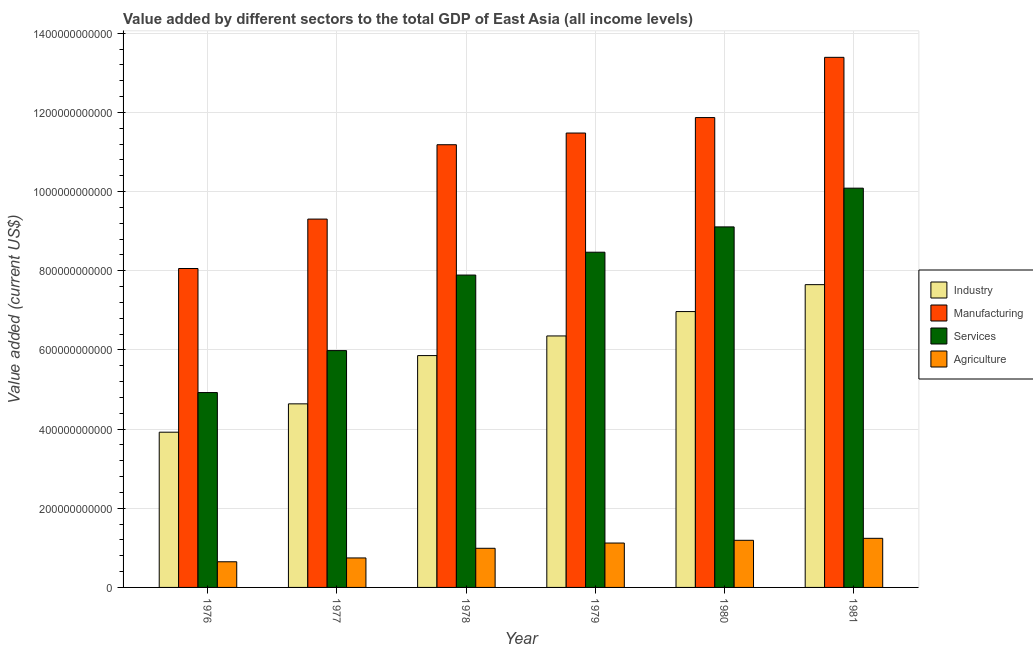How many different coloured bars are there?
Keep it short and to the point. 4. How many groups of bars are there?
Give a very brief answer. 6. Are the number of bars per tick equal to the number of legend labels?
Offer a terse response. Yes. Are the number of bars on each tick of the X-axis equal?
Offer a very short reply. Yes. What is the label of the 4th group of bars from the left?
Offer a very short reply. 1979. What is the value added by industrial sector in 1981?
Ensure brevity in your answer.  7.65e+11. Across all years, what is the maximum value added by manufacturing sector?
Your response must be concise. 1.34e+12. Across all years, what is the minimum value added by agricultural sector?
Provide a succinct answer. 6.48e+1. In which year was the value added by agricultural sector maximum?
Ensure brevity in your answer.  1981. In which year was the value added by industrial sector minimum?
Provide a succinct answer. 1976. What is the total value added by services sector in the graph?
Provide a succinct answer. 4.65e+12. What is the difference between the value added by services sector in 1977 and that in 1978?
Your answer should be very brief. -1.91e+11. What is the difference between the value added by services sector in 1979 and the value added by agricultural sector in 1977?
Provide a short and direct response. 2.49e+11. What is the average value added by services sector per year?
Ensure brevity in your answer.  7.74e+11. What is the ratio of the value added by industrial sector in 1978 to that in 1979?
Your answer should be very brief. 0.92. Is the value added by agricultural sector in 1977 less than that in 1978?
Make the answer very short. Yes. Is the difference between the value added by industrial sector in 1977 and 1980 greater than the difference between the value added by agricultural sector in 1977 and 1980?
Keep it short and to the point. No. What is the difference between the highest and the second highest value added by manufacturing sector?
Provide a short and direct response. 1.52e+11. What is the difference between the highest and the lowest value added by services sector?
Your answer should be very brief. 5.16e+11. Is the sum of the value added by manufacturing sector in 1976 and 1981 greater than the maximum value added by agricultural sector across all years?
Make the answer very short. Yes. What does the 1st bar from the left in 1977 represents?
Ensure brevity in your answer.  Industry. What does the 1st bar from the right in 1978 represents?
Give a very brief answer. Agriculture. Is it the case that in every year, the sum of the value added by industrial sector and value added by manufacturing sector is greater than the value added by services sector?
Your response must be concise. Yes. How many bars are there?
Your answer should be compact. 24. How many years are there in the graph?
Offer a terse response. 6. What is the difference between two consecutive major ticks on the Y-axis?
Offer a very short reply. 2.00e+11. Are the values on the major ticks of Y-axis written in scientific E-notation?
Ensure brevity in your answer.  No. Does the graph contain any zero values?
Your answer should be compact. No. How are the legend labels stacked?
Your response must be concise. Vertical. What is the title of the graph?
Make the answer very short. Value added by different sectors to the total GDP of East Asia (all income levels). What is the label or title of the Y-axis?
Provide a short and direct response. Value added (current US$). What is the Value added (current US$) of Industry in 1976?
Provide a short and direct response. 3.92e+11. What is the Value added (current US$) of Manufacturing in 1976?
Give a very brief answer. 8.06e+11. What is the Value added (current US$) of Services in 1976?
Provide a succinct answer. 4.92e+11. What is the Value added (current US$) in Agriculture in 1976?
Give a very brief answer. 6.48e+1. What is the Value added (current US$) of Industry in 1977?
Ensure brevity in your answer.  4.64e+11. What is the Value added (current US$) in Manufacturing in 1977?
Offer a very short reply. 9.31e+11. What is the Value added (current US$) in Services in 1977?
Your answer should be compact. 5.98e+11. What is the Value added (current US$) of Agriculture in 1977?
Keep it short and to the point. 7.45e+1. What is the Value added (current US$) of Industry in 1978?
Offer a terse response. 5.86e+11. What is the Value added (current US$) of Manufacturing in 1978?
Your response must be concise. 1.12e+12. What is the Value added (current US$) in Services in 1978?
Ensure brevity in your answer.  7.89e+11. What is the Value added (current US$) of Agriculture in 1978?
Your response must be concise. 9.89e+1. What is the Value added (current US$) in Industry in 1979?
Your response must be concise. 6.35e+11. What is the Value added (current US$) in Manufacturing in 1979?
Provide a short and direct response. 1.15e+12. What is the Value added (current US$) of Services in 1979?
Offer a very short reply. 8.47e+11. What is the Value added (current US$) of Agriculture in 1979?
Provide a short and direct response. 1.12e+11. What is the Value added (current US$) of Industry in 1980?
Provide a short and direct response. 6.97e+11. What is the Value added (current US$) in Manufacturing in 1980?
Your answer should be very brief. 1.19e+12. What is the Value added (current US$) of Services in 1980?
Offer a very short reply. 9.11e+11. What is the Value added (current US$) of Agriculture in 1980?
Ensure brevity in your answer.  1.19e+11. What is the Value added (current US$) of Industry in 1981?
Ensure brevity in your answer.  7.65e+11. What is the Value added (current US$) of Manufacturing in 1981?
Keep it short and to the point. 1.34e+12. What is the Value added (current US$) of Services in 1981?
Offer a very short reply. 1.01e+12. What is the Value added (current US$) of Agriculture in 1981?
Offer a terse response. 1.24e+11. Across all years, what is the maximum Value added (current US$) in Industry?
Your answer should be very brief. 7.65e+11. Across all years, what is the maximum Value added (current US$) of Manufacturing?
Ensure brevity in your answer.  1.34e+12. Across all years, what is the maximum Value added (current US$) in Services?
Your answer should be very brief. 1.01e+12. Across all years, what is the maximum Value added (current US$) of Agriculture?
Your response must be concise. 1.24e+11. Across all years, what is the minimum Value added (current US$) in Industry?
Offer a very short reply. 3.92e+11. Across all years, what is the minimum Value added (current US$) in Manufacturing?
Ensure brevity in your answer.  8.06e+11. Across all years, what is the minimum Value added (current US$) in Services?
Your response must be concise. 4.92e+11. Across all years, what is the minimum Value added (current US$) of Agriculture?
Provide a short and direct response. 6.48e+1. What is the total Value added (current US$) in Industry in the graph?
Your answer should be very brief. 3.54e+12. What is the total Value added (current US$) of Manufacturing in the graph?
Provide a succinct answer. 6.53e+12. What is the total Value added (current US$) of Services in the graph?
Offer a terse response. 4.65e+12. What is the total Value added (current US$) of Agriculture in the graph?
Ensure brevity in your answer.  5.93e+11. What is the difference between the Value added (current US$) in Industry in 1976 and that in 1977?
Your answer should be very brief. -7.16e+1. What is the difference between the Value added (current US$) in Manufacturing in 1976 and that in 1977?
Offer a very short reply. -1.25e+11. What is the difference between the Value added (current US$) of Services in 1976 and that in 1977?
Offer a very short reply. -1.06e+11. What is the difference between the Value added (current US$) of Agriculture in 1976 and that in 1977?
Your answer should be very brief. -9.68e+09. What is the difference between the Value added (current US$) of Industry in 1976 and that in 1978?
Provide a succinct answer. -1.94e+11. What is the difference between the Value added (current US$) in Manufacturing in 1976 and that in 1978?
Give a very brief answer. -3.13e+11. What is the difference between the Value added (current US$) of Services in 1976 and that in 1978?
Make the answer very short. -2.97e+11. What is the difference between the Value added (current US$) in Agriculture in 1976 and that in 1978?
Keep it short and to the point. -3.41e+1. What is the difference between the Value added (current US$) of Industry in 1976 and that in 1979?
Keep it short and to the point. -2.43e+11. What is the difference between the Value added (current US$) in Manufacturing in 1976 and that in 1979?
Provide a short and direct response. -3.42e+11. What is the difference between the Value added (current US$) in Services in 1976 and that in 1979?
Provide a short and direct response. -3.55e+11. What is the difference between the Value added (current US$) in Agriculture in 1976 and that in 1979?
Give a very brief answer. -4.73e+1. What is the difference between the Value added (current US$) of Industry in 1976 and that in 1980?
Make the answer very short. -3.05e+11. What is the difference between the Value added (current US$) of Manufacturing in 1976 and that in 1980?
Provide a short and direct response. -3.81e+11. What is the difference between the Value added (current US$) of Services in 1976 and that in 1980?
Make the answer very short. -4.18e+11. What is the difference between the Value added (current US$) in Agriculture in 1976 and that in 1980?
Keep it short and to the point. -5.42e+1. What is the difference between the Value added (current US$) in Industry in 1976 and that in 1981?
Give a very brief answer. -3.73e+11. What is the difference between the Value added (current US$) of Manufacturing in 1976 and that in 1981?
Your response must be concise. -5.33e+11. What is the difference between the Value added (current US$) of Services in 1976 and that in 1981?
Offer a terse response. -5.16e+11. What is the difference between the Value added (current US$) of Agriculture in 1976 and that in 1981?
Offer a terse response. -5.93e+1. What is the difference between the Value added (current US$) of Industry in 1977 and that in 1978?
Provide a short and direct response. -1.22e+11. What is the difference between the Value added (current US$) in Manufacturing in 1977 and that in 1978?
Provide a short and direct response. -1.88e+11. What is the difference between the Value added (current US$) in Services in 1977 and that in 1978?
Offer a terse response. -1.91e+11. What is the difference between the Value added (current US$) in Agriculture in 1977 and that in 1978?
Offer a very short reply. -2.44e+1. What is the difference between the Value added (current US$) in Industry in 1977 and that in 1979?
Provide a short and direct response. -1.72e+11. What is the difference between the Value added (current US$) in Manufacturing in 1977 and that in 1979?
Offer a very short reply. -2.17e+11. What is the difference between the Value added (current US$) in Services in 1977 and that in 1979?
Offer a terse response. -2.49e+11. What is the difference between the Value added (current US$) in Agriculture in 1977 and that in 1979?
Your answer should be compact. -3.76e+1. What is the difference between the Value added (current US$) of Industry in 1977 and that in 1980?
Provide a succinct answer. -2.33e+11. What is the difference between the Value added (current US$) in Manufacturing in 1977 and that in 1980?
Make the answer very short. -2.56e+11. What is the difference between the Value added (current US$) of Services in 1977 and that in 1980?
Provide a short and direct response. -3.13e+11. What is the difference between the Value added (current US$) in Agriculture in 1977 and that in 1980?
Your response must be concise. -4.46e+1. What is the difference between the Value added (current US$) of Industry in 1977 and that in 1981?
Keep it short and to the point. -3.01e+11. What is the difference between the Value added (current US$) of Manufacturing in 1977 and that in 1981?
Ensure brevity in your answer.  -4.09e+11. What is the difference between the Value added (current US$) of Services in 1977 and that in 1981?
Offer a very short reply. -4.10e+11. What is the difference between the Value added (current US$) in Agriculture in 1977 and that in 1981?
Keep it short and to the point. -4.96e+1. What is the difference between the Value added (current US$) of Industry in 1978 and that in 1979?
Your answer should be very brief. -4.96e+1. What is the difference between the Value added (current US$) in Manufacturing in 1978 and that in 1979?
Your answer should be compact. -2.95e+1. What is the difference between the Value added (current US$) in Services in 1978 and that in 1979?
Make the answer very short. -5.77e+1. What is the difference between the Value added (current US$) in Agriculture in 1978 and that in 1979?
Offer a very short reply. -1.33e+1. What is the difference between the Value added (current US$) in Industry in 1978 and that in 1980?
Make the answer very short. -1.11e+11. What is the difference between the Value added (current US$) in Manufacturing in 1978 and that in 1980?
Offer a terse response. -6.86e+1. What is the difference between the Value added (current US$) in Services in 1978 and that in 1980?
Give a very brief answer. -1.22e+11. What is the difference between the Value added (current US$) in Agriculture in 1978 and that in 1980?
Your response must be concise. -2.02e+1. What is the difference between the Value added (current US$) in Industry in 1978 and that in 1981?
Keep it short and to the point. -1.79e+11. What is the difference between the Value added (current US$) in Manufacturing in 1978 and that in 1981?
Your answer should be very brief. -2.21e+11. What is the difference between the Value added (current US$) of Services in 1978 and that in 1981?
Provide a short and direct response. -2.20e+11. What is the difference between the Value added (current US$) in Agriculture in 1978 and that in 1981?
Ensure brevity in your answer.  -2.52e+1. What is the difference between the Value added (current US$) in Industry in 1979 and that in 1980?
Ensure brevity in your answer.  -6.16e+1. What is the difference between the Value added (current US$) in Manufacturing in 1979 and that in 1980?
Provide a short and direct response. -3.91e+1. What is the difference between the Value added (current US$) of Services in 1979 and that in 1980?
Your response must be concise. -6.40e+1. What is the difference between the Value added (current US$) of Agriculture in 1979 and that in 1980?
Provide a succinct answer. -6.93e+09. What is the difference between the Value added (current US$) of Industry in 1979 and that in 1981?
Ensure brevity in your answer.  -1.30e+11. What is the difference between the Value added (current US$) in Manufacturing in 1979 and that in 1981?
Offer a terse response. -1.91e+11. What is the difference between the Value added (current US$) in Services in 1979 and that in 1981?
Provide a succinct answer. -1.62e+11. What is the difference between the Value added (current US$) of Agriculture in 1979 and that in 1981?
Offer a very short reply. -1.20e+1. What is the difference between the Value added (current US$) in Industry in 1980 and that in 1981?
Offer a very short reply. -6.80e+1. What is the difference between the Value added (current US$) in Manufacturing in 1980 and that in 1981?
Give a very brief answer. -1.52e+11. What is the difference between the Value added (current US$) of Services in 1980 and that in 1981?
Your answer should be very brief. -9.78e+1. What is the difference between the Value added (current US$) of Agriculture in 1980 and that in 1981?
Provide a succinct answer. -5.02e+09. What is the difference between the Value added (current US$) in Industry in 1976 and the Value added (current US$) in Manufacturing in 1977?
Make the answer very short. -5.38e+11. What is the difference between the Value added (current US$) of Industry in 1976 and the Value added (current US$) of Services in 1977?
Offer a very short reply. -2.06e+11. What is the difference between the Value added (current US$) in Industry in 1976 and the Value added (current US$) in Agriculture in 1977?
Provide a short and direct response. 3.18e+11. What is the difference between the Value added (current US$) of Manufacturing in 1976 and the Value added (current US$) of Services in 1977?
Offer a very short reply. 2.07e+11. What is the difference between the Value added (current US$) of Manufacturing in 1976 and the Value added (current US$) of Agriculture in 1977?
Provide a short and direct response. 7.31e+11. What is the difference between the Value added (current US$) in Services in 1976 and the Value added (current US$) in Agriculture in 1977?
Provide a succinct answer. 4.18e+11. What is the difference between the Value added (current US$) in Industry in 1976 and the Value added (current US$) in Manufacturing in 1978?
Ensure brevity in your answer.  -7.26e+11. What is the difference between the Value added (current US$) of Industry in 1976 and the Value added (current US$) of Services in 1978?
Provide a succinct answer. -3.97e+11. What is the difference between the Value added (current US$) in Industry in 1976 and the Value added (current US$) in Agriculture in 1978?
Offer a terse response. 2.93e+11. What is the difference between the Value added (current US$) in Manufacturing in 1976 and the Value added (current US$) in Services in 1978?
Make the answer very short. 1.65e+1. What is the difference between the Value added (current US$) in Manufacturing in 1976 and the Value added (current US$) in Agriculture in 1978?
Offer a very short reply. 7.07e+11. What is the difference between the Value added (current US$) in Services in 1976 and the Value added (current US$) in Agriculture in 1978?
Provide a short and direct response. 3.93e+11. What is the difference between the Value added (current US$) in Industry in 1976 and the Value added (current US$) in Manufacturing in 1979?
Give a very brief answer. -7.56e+11. What is the difference between the Value added (current US$) in Industry in 1976 and the Value added (current US$) in Services in 1979?
Your response must be concise. -4.55e+11. What is the difference between the Value added (current US$) of Industry in 1976 and the Value added (current US$) of Agriculture in 1979?
Give a very brief answer. 2.80e+11. What is the difference between the Value added (current US$) of Manufacturing in 1976 and the Value added (current US$) of Services in 1979?
Give a very brief answer. -4.12e+1. What is the difference between the Value added (current US$) of Manufacturing in 1976 and the Value added (current US$) of Agriculture in 1979?
Ensure brevity in your answer.  6.94e+11. What is the difference between the Value added (current US$) in Services in 1976 and the Value added (current US$) in Agriculture in 1979?
Make the answer very short. 3.80e+11. What is the difference between the Value added (current US$) in Industry in 1976 and the Value added (current US$) in Manufacturing in 1980?
Provide a succinct answer. -7.95e+11. What is the difference between the Value added (current US$) in Industry in 1976 and the Value added (current US$) in Services in 1980?
Provide a succinct answer. -5.19e+11. What is the difference between the Value added (current US$) in Industry in 1976 and the Value added (current US$) in Agriculture in 1980?
Your answer should be very brief. 2.73e+11. What is the difference between the Value added (current US$) in Manufacturing in 1976 and the Value added (current US$) in Services in 1980?
Offer a very short reply. -1.05e+11. What is the difference between the Value added (current US$) in Manufacturing in 1976 and the Value added (current US$) in Agriculture in 1980?
Keep it short and to the point. 6.87e+11. What is the difference between the Value added (current US$) of Services in 1976 and the Value added (current US$) of Agriculture in 1980?
Make the answer very short. 3.73e+11. What is the difference between the Value added (current US$) of Industry in 1976 and the Value added (current US$) of Manufacturing in 1981?
Your answer should be compact. -9.47e+11. What is the difference between the Value added (current US$) in Industry in 1976 and the Value added (current US$) in Services in 1981?
Your answer should be compact. -6.16e+11. What is the difference between the Value added (current US$) of Industry in 1976 and the Value added (current US$) of Agriculture in 1981?
Provide a short and direct response. 2.68e+11. What is the difference between the Value added (current US$) in Manufacturing in 1976 and the Value added (current US$) in Services in 1981?
Your answer should be compact. -2.03e+11. What is the difference between the Value added (current US$) in Manufacturing in 1976 and the Value added (current US$) in Agriculture in 1981?
Your answer should be very brief. 6.82e+11. What is the difference between the Value added (current US$) of Services in 1976 and the Value added (current US$) of Agriculture in 1981?
Offer a very short reply. 3.68e+11. What is the difference between the Value added (current US$) in Industry in 1977 and the Value added (current US$) in Manufacturing in 1978?
Give a very brief answer. -6.55e+11. What is the difference between the Value added (current US$) of Industry in 1977 and the Value added (current US$) of Services in 1978?
Provide a succinct answer. -3.25e+11. What is the difference between the Value added (current US$) of Industry in 1977 and the Value added (current US$) of Agriculture in 1978?
Your answer should be compact. 3.65e+11. What is the difference between the Value added (current US$) in Manufacturing in 1977 and the Value added (current US$) in Services in 1978?
Provide a succinct answer. 1.41e+11. What is the difference between the Value added (current US$) in Manufacturing in 1977 and the Value added (current US$) in Agriculture in 1978?
Your answer should be very brief. 8.32e+11. What is the difference between the Value added (current US$) of Services in 1977 and the Value added (current US$) of Agriculture in 1978?
Make the answer very short. 4.99e+11. What is the difference between the Value added (current US$) of Industry in 1977 and the Value added (current US$) of Manufacturing in 1979?
Your answer should be compact. -6.84e+11. What is the difference between the Value added (current US$) of Industry in 1977 and the Value added (current US$) of Services in 1979?
Give a very brief answer. -3.83e+11. What is the difference between the Value added (current US$) in Industry in 1977 and the Value added (current US$) in Agriculture in 1979?
Your response must be concise. 3.52e+11. What is the difference between the Value added (current US$) in Manufacturing in 1977 and the Value added (current US$) in Services in 1979?
Your response must be concise. 8.37e+1. What is the difference between the Value added (current US$) of Manufacturing in 1977 and the Value added (current US$) of Agriculture in 1979?
Your response must be concise. 8.18e+11. What is the difference between the Value added (current US$) in Services in 1977 and the Value added (current US$) in Agriculture in 1979?
Make the answer very short. 4.86e+11. What is the difference between the Value added (current US$) of Industry in 1977 and the Value added (current US$) of Manufacturing in 1980?
Offer a terse response. -7.23e+11. What is the difference between the Value added (current US$) in Industry in 1977 and the Value added (current US$) in Services in 1980?
Ensure brevity in your answer.  -4.47e+11. What is the difference between the Value added (current US$) in Industry in 1977 and the Value added (current US$) in Agriculture in 1980?
Make the answer very short. 3.45e+11. What is the difference between the Value added (current US$) in Manufacturing in 1977 and the Value added (current US$) in Services in 1980?
Make the answer very short. 1.97e+1. What is the difference between the Value added (current US$) of Manufacturing in 1977 and the Value added (current US$) of Agriculture in 1980?
Offer a very short reply. 8.11e+11. What is the difference between the Value added (current US$) in Services in 1977 and the Value added (current US$) in Agriculture in 1980?
Offer a terse response. 4.79e+11. What is the difference between the Value added (current US$) in Industry in 1977 and the Value added (current US$) in Manufacturing in 1981?
Keep it short and to the point. -8.75e+11. What is the difference between the Value added (current US$) of Industry in 1977 and the Value added (current US$) of Services in 1981?
Ensure brevity in your answer.  -5.45e+11. What is the difference between the Value added (current US$) of Industry in 1977 and the Value added (current US$) of Agriculture in 1981?
Ensure brevity in your answer.  3.40e+11. What is the difference between the Value added (current US$) in Manufacturing in 1977 and the Value added (current US$) in Services in 1981?
Your answer should be compact. -7.81e+1. What is the difference between the Value added (current US$) of Manufacturing in 1977 and the Value added (current US$) of Agriculture in 1981?
Offer a terse response. 8.06e+11. What is the difference between the Value added (current US$) of Services in 1977 and the Value added (current US$) of Agriculture in 1981?
Provide a short and direct response. 4.74e+11. What is the difference between the Value added (current US$) in Industry in 1978 and the Value added (current US$) in Manufacturing in 1979?
Provide a succinct answer. -5.62e+11. What is the difference between the Value added (current US$) in Industry in 1978 and the Value added (current US$) in Services in 1979?
Offer a terse response. -2.61e+11. What is the difference between the Value added (current US$) of Industry in 1978 and the Value added (current US$) of Agriculture in 1979?
Provide a short and direct response. 4.74e+11. What is the difference between the Value added (current US$) of Manufacturing in 1978 and the Value added (current US$) of Services in 1979?
Ensure brevity in your answer.  2.72e+11. What is the difference between the Value added (current US$) in Manufacturing in 1978 and the Value added (current US$) in Agriculture in 1979?
Offer a very short reply. 1.01e+12. What is the difference between the Value added (current US$) of Services in 1978 and the Value added (current US$) of Agriculture in 1979?
Make the answer very short. 6.77e+11. What is the difference between the Value added (current US$) of Industry in 1978 and the Value added (current US$) of Manufacturing in 1980?
Offer a very short reply. -6.01e+11. What is the difference between the Value added (current US$) of Industry in 1978 and the Value added (current US$) of Services in 1980?
Give a very brief answer. -3.25e+11. What is the difference between the Value added (current US$) of Industry in 1978 and the Value added (current US$) of Agriculture in 1980?
Provide a short and direct response. 4.67e+11. What is the difference between the Value added (current US$) in Manufacturing in 1978 and the Value added (current US$) in Services in 1980?
Offer a very short reply. 2.08e+11. What is the difference between the Value added (current US$) of Manufacturing in 1978 and the Value added (current US$) of Agriculture in 1980?
Ensure brevity in your answer.  9.99e+11. What is the difference between the Value added (current US$) of Services in 1978 and the Value added (current US$) of Agriculture in 1980?
Your response must be concise. 6.70e+11. What is the difference between the Value added (current US$) of Industry in 1978 and the Value added (current US$) of Manufacturing in 1981?
Your response must be concise. -7.53e+11. What is the difference between the Value added (current US$) of Industry in 1978 and the Value added (current US$) of Services in 1981?
Your answer should be very brief. -4.23e+11. What is the difference between the Value added (current US$) of Industry in 1978 and the Value added (current US$) of Agriculture in 1981?
Make the answer very short. 4.62e+11. What is the difference between the Value added (current US$) of Manufacturing in 1978 and the Value added (current US$) of Services in 1981?
Offer a terse response. 1.10e+11. What is the difference between the Value added (current US$) in Manufacturing in 1978 and the Value added (current US$) in Agriculture in 1981?
Offer a very short reply. 9.94e+11. What is the difference between the Value added (current US$) of Services in 1978 and the Value added (current US$) of Agriculture in 1981?
Ensure brevity in your answer.  6.65e+11. What is the difference between the Value added (current US$) of Industry in 1979 and the Value added (current US$) of Manufacturing in 1980?
Your answer should be compact. -5.52e+11. What is the difference between the Value added (current US$) of Industry in 1979 and the Value added (current US$) of Services in 1980?
Provide a short and direct response. -2.75e+11. What is the difference between the Value added (current US$) in Industry in 1979 and the Value added (current US$) in Agriculture in 1980?
Keep it short and to the point. 5.16e+11. What is the difference between the Value added (current US$) of Manufacturing in 1979 and the Value added (current US$) of Services in 1980?
Offer a very short reply. 2.37e+11. What is the difference between the Value added (current US$) of Manufacturing in 1979 and the Value added (current US$) of Agriculture in 1980?
Your answer should be compact. 1.03e+12. What is the difference between the Value added (current US$) of Services in 1979 and the Value added (current US$) of Agriculture in 1980?
Your response must be concise. 7.28e+11. What is the difference between the Value added (current US$) in Industry in 1979 and the Value added (current US$) in Manufacturing in 1981?
Provide a short and direct response. -7.04e+11. What is the difference between the Value added (current US$) of Industry in 1979 and the Value added (current US$) of Services in 1981?
Offer a terse response. -3.73e+11. What is the difference between the Value added (current US$) of Industry in 1979 and the Value added (current US$) of Agriculture in 1981?
Ensure brevity in your answer.  5.11e+11. What is the difference between the Value added (current US$) in Manufacturing in 1979 and the Value added (current US$) in Services in 1981?
Offer a terse response. 1.39e+11. What is the difference between the Value added (current US$) of Manufacturing in 1979 and the Value added (current US$) of Agriculture in 1981?
Keep it short and to the point. 1.02e+12. What is the difference between the Value added (current US$) in Services in 1979 and the Value added (current US$) in Agriculture in 1981?
Offer a very short reply. 7.23e+11. What is the difference between the Value added (current US$) of Industry in 1980 and the Value added (current US$) of Manufacturing in 1981?
Your response must be concise. -6.42e+11. What is the difference between the Value added (current US$) of Industry in 1980 and the Value added (current US$) of Services in 1981?
Your answer should be compact. -3.12e+11. What is the difference between the Value added (current US$) in Industry in 1980 and the Value added (current US$) in Agriculture in 1981?
Ensure brevity in your answer.  5.73e+11. What is the difference between the Value added (current US$) of Manufacturing in 1980 and the Value added (current US$) of Services in 1981?
Ensure brevity in your answer.  1.78e+11. What is the difference between the Value added (current US$) in Manufacturing in 1980 and the Value added (current US$) in Agriculture in 1981?
Provide a succinct answer. 1.06e+12. What is the difference between the Value added (current US$) of Services in 1980 and the Value added (current US$) of Agriculture in 1981?
Provide a succinct answer. 7.87e+11. What is the average Value added (current US$) in Industry per year?
Provide a short and direct response. 5.90e+11. What is the average Value added (current US$) of Manufacturing per year?
Provide a succinct answer. 1.09e+12. What is the average Value added (current US$) in Services per year?
Provide a succinct answer. 7.74e+11. What is the average Value added (current US$) in Agriculture per year?
Give a very brief answer. 9.89e+1. In the year 1976, what is the difference between the Value added (current US$) of Industry and Value added (current US$) of Manufacturing?
Keep it short and to the point. -4.14e+11. In the year 1976, what is the difference between the Value added (current US$) in Industry and Value added (current US$) in Services?
Your answer should be compact. -1.00e+11. In the year 1976, what is the difference between the Value added (current US$) in Industry and Value added (current US$) in Agriculture?
Give a very brief answer. 3.27e+11. In the year 1976, what is the difference between the Value added (current US$) of Manufacturing and Value added (current US$) of Services?
Your answer should be compact. 3.13e+11. In the year 1976, what is the difference between the Value added (current US$) of Manufacturing and Value added (current US$) of Agriculture?
Offer a very short reply. 7.41e+11. In the year 1976, what is the difference between the Value added (current US$) of Services and Value added (current US$) of Agriculture?
Ensure brevity in your answer.  4.27e+11. In the year 1977, what is the difference between the Value added (current US$) of Industry and Value added (current US$) of Manufacturing?
Keep it short and to the point. -4.67e+11. In the year 1977, what is the difference between the Value added (current US$) of Industry and Value added (current US$) of Services?
Your response must be concise. -1.35e+11. In the year 1977, what is the difference between the Value added (current US$) of Industry and Value added (current US$) of Agriculture?
Offer a terse response. 3.89e+11. In the year 1977, what is the difference between the Value added (current US$) of Manufacturing and Value added (current US$) of Services?
Ensure brevity in your answer.  3.32e+11. In the year 1977, what is the difference between the Value added (current US$) in Manufacturing and Value added (current US$) in Agriculture?
Provide a succinct answer. 8.56e+11. In the year 1977, what is the difference between the Value added (current US$) of Services and Value added (current US$) of Agriculture?
Offer a very short reply. 5.24e+11. In the year 1978, what is the difference between the Value added (current US$) in Industry and Value added (current US$) in Manufacturing?
Your answer should be compact. -5.33e+11. In the year 1978, what is the difference between the Value added (current US$) of Industry and Value added (current US$) of Services?
Provide a short and direct response. -2.03e+11. In the year 1978, what is the difference between the Value added (current US$) in Industry and Value added (current US$) in Agriculture?
Offer a terse response. 4.87e+11. In the year 1978, what is the difference between the Value added (current US$) of Manufacturing and Value added (current US$) of Services?
Make the answer very short. 3.29e+11. In the year 1978, what is the difference between the Value added (current US$) of Manufacturing and Value added (current US$) of Agriculture?
Offer a terse response. 1.02e+12. In the year 1978, what is the difference between the Value added (current US$) of Services and Value added (current US$) of Agriculture?
Your response must be concise. 6.90e+11. In the year 1979, what is the difference between the Value added (current US$) in Industry and Value added (current US$) in Manufacturing?
Make the answer very short. -5.13e+11. In the year 1979, what is the difference between the Value added (current US$) in Industry and Value added (current US$) in Services?
Your answer should be very brief. -2.12e+11. In the year 1979, what is the difference between the Value added (current US$) in Industry and Value added (current US$) in Agriculture?
Your answer should be compact. 5.23e+11. In the year 1979, what is the difference between the Value added (current US$) of Manufacturing and Value added (current US$) of Services?
Your response must be concise. 3.01e+11. In the year 1979, what is the difference between the Value added (current US$) of Manufacturing and Value added (current US$) of Agriculture?
Keep it short and to the point. 1.04e+12. In the year 1979, what is the difference between the Value added (current US$) in Services and Value added (current US$) in Agriculture?
Offer a very short reply. 7.35e+11. In the year 1980, what is the difference between the Value added (current US$) in Industry and Value added (current US$) in Manufacturing?
Provide a succinct answer. -4.90e+11. In the year 1980, what is the difference between the Value added (current US$) of Industry and Value added (current US$) of Services?
Your answer should be very brief. -2.14e+11. In the year 1980, what is the difference between the Value added (current US$) of Industry and Value added (current US$) of Agriculture?
Your answer should be very brief. 5.78e+11. In the year 1980, what is the difference between the Value added (current US$) of Manufacturing and Value added (current US$) of Services?
Ensure brevity in your answer.  2.76e+11. In the year 1980, what is the difference between the Value added (current US$) in Manufacturing and Value added (current US$) in Agriculture?
Your response must be concise. 1.07e+12. In the year 1980, what is the difference between the Value added (current US$) of Services and Value added (current US$) of Agriculture?
Ensure brevity in your answer.  7.92e+11. In the year 1981, what is the difference between the Value added (current US$) of Industry and Value added (current US$) of Manufacturing?
Offer a terse response. -5.74e+11. In the year 1981, what is the difference between the Value added (current US$) in Industry and Value added (current US$) in Services?
Provide a succinct answer. -2.44e+11. In the year 1981, what is the difference between the Value added (current US$) of Industry and Value added (current US$) of Agriculture?
Provide a succinct answer. 6.41e+11. In the year 1981, what is the difference between the Value added (current US$) in Manufacturing and Value added (current US$) in Services?
Keep it short and to the point. 3.31e+11. In the year 1981, what is the difference between the Value added (current US$) in Manufacturing and Value added (current US$) in Agriculture?
Make the answer very short. 1.22e+12. In the year 1981, what is the difference between the Value added (current US$) in Services and Value added (current US$) in Agriculture?
Provide a succinct answer. 8.85e+11. What is the ratio of the Value added (current US$) in Industry in 1976 to that in 1977?
Ensure brevity in your answer.  0.85. What is the ratio of the Value added (current US$) in Manufacturing in 1976 to that in 1977?
Make the answer very short. 0.87. What is the ratio of the Value added (current US$) in Services in 1976 to that in 1977?
Make the answer very short. 0.82. What is the ratio of the Value added (current US$) of Agriculture in 1976 to that in 1977?
Your answer should be very brief. 0.87. What is the ratio of the Value added (current US$) in Industry in 1976 to that in 1978?
Your response must be concise. 0.67. What is the ratio of the Value added (current US$) in Manufacturing in 1976 to that in 1978?
Your answer should be compact. 0.72. What is the ratio of the Value added (current US$) of Services in 1976 to that in 1978?
Keep it short and to the point. 0.62. What is the ratio of the Value added (current US$) in Agriculture in 1976 to that in 1978?
Provide a succinct answer. 0.66. What is the ratio of the Value added (current US$) of Industry in 1976 to that in 1979?
Your answer should be compact. 0.62. What is the ratio of the Value added (current US$) in Manufacturing in 1976 to that in 1979?
Offer a very short reply. 0.7. What is the ratio of the Value added (current US$) of Services in 1976 to that in 1979?
Give a very brief answer. 0.58. What is the ratio of the Value added (current US$) of Agriculture in 1976 to that in 1979?
Your answer should be compact. 0.58. What is the ratio of the Value added (current US$) in Industry in 1976 to that in 1980?
Provide a short and direct response. 0.56. What is the ratio of the Value added (current US$) of Manufacturing in 1976 to that in 1980?
Make the answer very short. 0.68. What is the ratio of the Value added (current US$) of Services in 1976 to that in 1980?
Your answer should be compact. 0.54. What is the ratio of the Value added (current US$) in Agriculture in 1976 to that in 1980?
Provide a short and direct response. 0.54. What is the ratio of the Value added (current US$) in Industry in 1976 to that in 1981?
Your answer should be very brief. 0.51. What is the ratio of the Value added (current US$) in Manufacturing in 1976 to that in 1981?
Your answer should be very brief. 0.6. What is the ratio of the Value added (current US$) of Services in 1976 to that in 1981?
Your answer should be compact. 0.49. What is the ratio of the Value added (current US$) of Agriculture in 1976 to that in 1981?
Offer a terse response. 0.52. What is the ratio of the Value added (current US$) in Industry in 1977 to that in 1978?
Give a very brief answer. 0.79. What is the ratio of the Value added (current US$) of Manufacturing in 1977 to that in 1978?
Offer a terse response. 0.83. What is the ratio of the Value added (current US$) of Services in 1977 to that in 1978?
Provide a short and direct response. 0.76. What is the ratio of the Value added (current US$) of Agriculture in 1977 to that in 1978?
Your answer should be compact. 0.75. What is the ratio of the Value added (current US$) in Industry in 1977 to that in 1979?
Provide a succinct answer. 0.73. What is the ratio of the Value added (current US$) in Manufacturing in 1977 to that in 1979?
Provide a succinct answer. 0.81. What is the ratio of the Value added (current US$) of Services in 1977 to that in 1979?
Offer a very short reply. 0.71. What is the ratio of the Value added (current US$) of Agriculture in 1977 to that in 1979?
Offer a terse response. 0.66. What is the ratio of the Value added (current US$) in Industry in 1977 to that in 1980?
Offer a terse response. 0.67. What is the ratio of the Value added (current US$) of Manufacturing in 1977 to that in 1980?
Your answer should be very brief. 0.78. What is the ratio of the Value added (current US$) of Services in 1977 to that in 1980?
Your answer should be very brief. 0.66. What is the ratio of the Value added (current US$) in Agriculture in 1977 to that in 1980?
Your answer should be compact. 0.63. What is the ratio of the Value added (current US$) in Industry in 1977 to that in 1981?
Your answer should be very brief. 0.61. What is the ratio of the Value added (current US$) of Manufacturing in 1977 to that in 1981?
Provide a short and direct response. 0.69. What is the ratio of the Value added (current US$) in Services in 1977 to that in 1981?
Make the answer very short. 0.59. What is the ratio of the Value added (current US$) of Agriculture in 1977 to that in 1981?
Offer a very short reply. 0.6. What is the ratio of the Value added (current US$) of Industry in 1978 to that in 1979?
Your response must be concise. 0.92. What is the ratio of the Value added (current US$) of Manufacturing in 1978 to that in 1979?
Ensure brevity in your answer.  0.97. What is the ratio of the Value added (current US$) in Services in 1978 to that in 1979?
Your response must be concise. 0.93. What is the ratio of the Value added (current US$) of Agriculture in 1978 to that in 1979?
Give a very brief answer. 0.88. What is the ratio of the Value added (current US$) of Industry in 1978 to that in 1980?
Keep it short and to the point. 0.84. What is the ratio of the Value added (current US$) of Manufacturing in 1978 to that in 1980?
Ensure brevity in your answer.  0.94. What is the ratio of the Value added (current US$) of Services in 1978 to that in 1980?
Provide a short and direct response. 0.87. What is the ratio of the Value added (current US$) of Agriculture in 1978 to that in 1980?
Offer a terse response. 0.83. What is the ratio of the Value added (current US$) in Industry in 1978 to that in 1981?
Make the answer very short. 0.77. What is the ratio of the Value added (current US$) in Manufacturing in 1978 to that in 1981?
Offer a terse response. 0.84. What is the ratio of the Value added (current US$) of Services in 1978 to that in 1981?
Offer a terse response. 0.78. What is the ratio of the Value added (current US$) in Agriculture in 1978 to that in 1981?
Make the answer very short. 0.8. What is the ratio of the Value added (current US$) in Industry in 1979 to that in 1980?
Keep it short and to the point. 0.91. What is the ratio of the Value added (current US$) in Manufacturing in 1979 to that in 1980?
Ensure brevity in your answer.  0.97. What is the ratio of the Value added (current US$) of Services in 1979 to that in 1980?
Make the answer very short. 0.93. What is the ratio of the Value added (current US$) of Agriculture in 1979 to that in 1980?
Your answer should be compact. 0.94. What is the ratio of the Value added (current US$) of Industry in 1979 to that in 1981?
Provide a short and direct response. 0.83. What is the ratio of the Value added (current US$) in Manufacturing in 1979 to that in 1981?
Make the answer very short. 0.86. What is the ratio of the Value added (current US$) of Services in 1979 to that in 1981?
Ensure brevity in your answer.  0.84. What is the ratio of the Value added (current US$) of Agriculture in 1979 to that in 1981?
Your answer should be very brief. 0.9. What is the ratio of the Value added (current US$) of Industry in 1980 to that in 1981?
Make the answer very short. 0.91. What is the ratio of the Value added (current US$) in Manufacturing in 1980 to that in 1981?
Offer a terse response. 0.89. What is the ratio of the Value added (current US$) of Services in 1980 to that in 1981?
Offer a terse response. 0.9. What is the ratio of the Value added (current US$) of Agriculture in 1980 to that in 1981?
Provide a short and direct response. 0.96. What is the difference between the highest and the second highest Value added (current US$) in Industry?
Offer a very short reply. 6.80e+1. What is the difference between the highest and the second highest Value added (current US$) in Manufacturing?
Your answer should be very brief. 1.52e+11. What is the difference between the highest and the second highest Value added (current US$) of Services?
Provide a succinct answer. 9.78e+1. What is the difference between the highest and the second highest Value added (current US$) in Agriculture?
Your answer should be compact. 5.02e+09. What is the difference between the highest and the lowest Value added (current US$) in Industry?
Provide a short and direct response. 3.73e+11. What is the difference between the highest and the lowest Value added (current US$) in Manufacturing?
Ensure brevity in your answer.  5.33e+11. What is the difference between the highest and the lowest Value added (current US$) of Services?
Ensure brevity in your answer.  5.16e+11. What is the difference between the highest and the lowest Value added (current US$) in Agriculture?
Provide a short and direct response. 5.93e+1. 